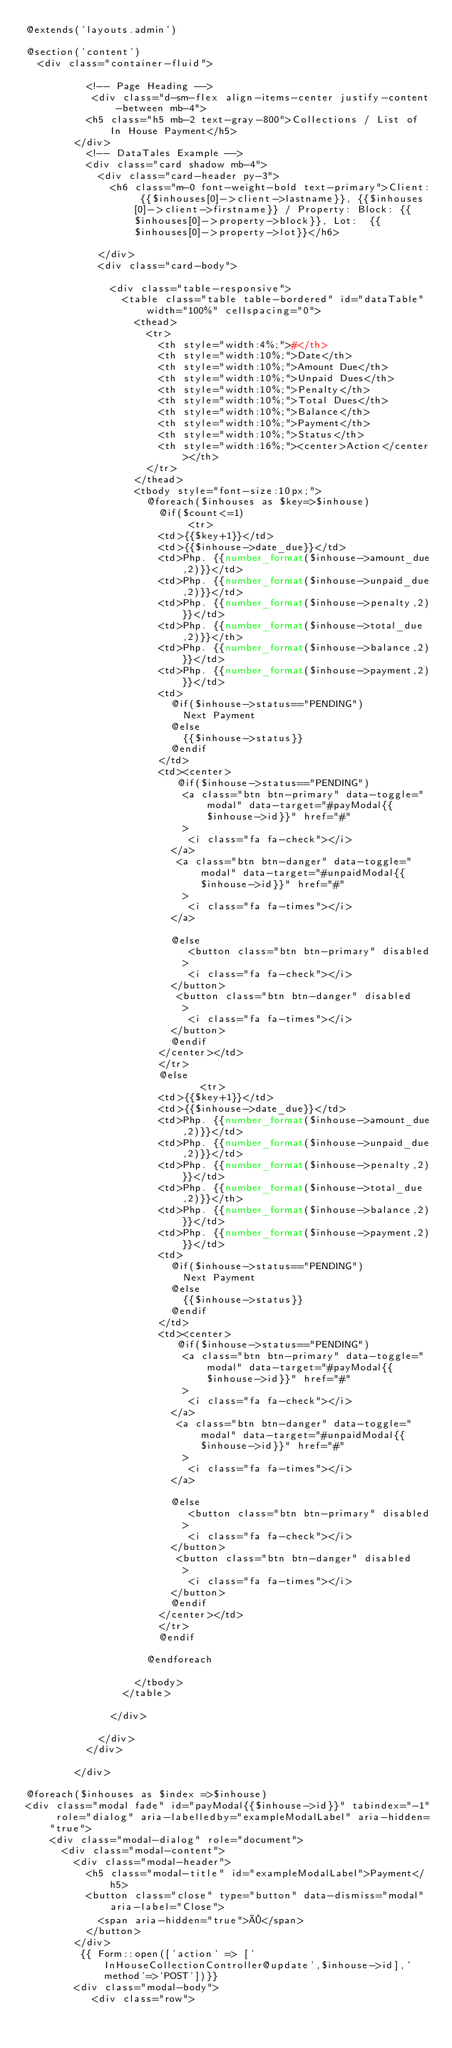<code> <loc_0><loc_0><loc_500><loc_500><_PHP_>@extends('layouts.admin')

@section('content')
  <div class="container-fluid">

          <!-- Page Heading -->
           <div class="d-sm-flex align-items-center justify-content-between mb-4">
          <h5 class="h5 mb-2 text-gray-800">Collections / List of In House Payment</h5>
        </div>
          <!-- DataTales Example -->
          <div class="card shadow mb-4">
            <div class="card-header py-3">
              <h6 class="m-0 font-weight-bold text-primary">Client: {{$inhouses[0]->client->lastname}}, {{$inhouses[0]->client->firstname}} / Property: Block: {{$inhouses[0]->property->block}}, Lot:  {{$inhouses[0]->property->lot}}</h6>

            </div>
            <div class="card-body">
            
              <div class="table-responsive">
                <table class="table table-bordered" id="dataTable" width="100%" cellspacing="0">
                  <thead>
                    <tr>
                      <th style="width:4%;">#</th>
                      <th style="width:10%;">Date</th>
                      <th style="width:10%;">Amount Due</th>
                      <th style="width:10%;">Unpaid Dues</th>
                      <th style="width:10%;">Penalty</th>
                      <th style="width:10%;">Total Dues</th>
                      <th style="width:10%;">Balance</th>
                      <th style="width:10%;">Payment</th>
                      <th style="width:10%;">Status</th>
                      <th style="width:16%;"><center>Action</center></th>
                    </tr>
                  </thead>
                  <tbody style="font-size:10px;">
                    @foreach($inhouses as $key=>$inhouse)
                      @if($count<=1)
                           <tr>
                      <td>{{$key+1}}</td>
                      <td>{{$inhouse->date_due}}</td>
                      <td>Php. {{number_format($inhouse->amount_due,2)}}</td>
                      <td>Php. {{number_format($inhouse->unpaid_due,2)}}</td>
                      <td>Php. {{number_format($inhouse->penalty,2)}}</td>
                      <td>Php. {{number_format($inhouse->total_due,2)}}</th>
                      <td>Php. {{number_format($inhouse->balance,2)}}</td>
                      <td>Php. {{number_format($inhouse->payment,2)}}</td>
                      <td>
                        @if($inhouse->status=="PENDING")
                          Next Payment
                        @else
                          {{$inhouse->status}}
                        @endif
                      </td>
                      <td><center>
                         @if($inhouse->status=="PENDING")
                          <a class="btn btn-primary" data-toggle="modal" data-target="#payModal{{$inhouse->id}}" href="#"
                          >
                           <i class="fa fa-check"></i>
                        </a>
                         <a class="btn btn-danger" data-toggle="modal" data-target="#unpaidModal{{$inhouse->id}}" href="#"
                          >
                           <i class="fa fa-times"></i>
                        </a>
                       
                        @else
                           <button class="btn btn-primary" disabled
                          >
                           <i class="fa fa-check"></i>
                        </button>
                         <button class="btn btn-danger" disabled
                          >
                           <i class="fa fa-times"></i>
                        </button>
                        @endif
                      </center></td>
                      </tr>
                      @else
                             <tr>
                      <td>{{$key+1}}</td>
                      <td>{{$inhouse->date_due}}</td>
                      <td>Php. {{number_format($inhouse->amount_due,2)}}</td>
                      <td>Php. {{number_format($inhouse->unpaid_due,2)}}</td>
                      <td>Php. {{number_format($inhouse->penalty,2)}}</td>
                      <td>Php. {{number_format($inhouse->total_due,2)}}</th>
                      <td>Php. {{number_format($inhouse->balance,2)}}</td>
                      <td>Php. {{number_format($inhouse->payment,2)}}</td>
                      <td>
                        @if($inhouse->status=="PENDING")
                          Next Payment
                        @else
                          {{$inhouse->status}}
                        @endif
                      </td>
                      <td><center>
                         @if($inhouse->status=="PENDING")
                          <a class="btn btn-primary" data-toggle="modal" data-target="#payModal{{$inhouse->id}}" href="#"
                          >
                           <i class="fa fa-check"></i>
                        </a>
                         <a class="btn btn-danger" data-toggle="modal" data-target="#unpaidModal{{$inhouse->id}}" href="#"
                          >
                           <i class="fa fa-times"></i>
                        </a>
                       
                        @else
                           <button class="btn btn-primary" disabled
                          >
                           <i class="fa fa-check"></i>
                        </button>
                         <button class="btn btn-danger" disabled
                          >
                           <i class="fa fa-times"></i>
                        </button>
                        @endif
                      </center></td>
                      </tr>
                      @endif
                   
                    @endforeach
                     
                  </tbody>
                </table>
              
              </div>
            
            </div>
          </div>

        </div>

@foreach($inhouses as $index =>$inhouse)
<div class="modal fade" id="payModal{{$inhouse->id}}" tabindex="-1" role="dialog" aria-labelledby="exampleModalLabel" aria-hidden="true">
    <div class="modal-dialog" role="document">
      <div class="modal-content">
        <div class="modal-header">
          <h5 class="modal-title" id="exampleModalLabel">Payment</h5>
          <button class="close" type="button" data-dismiss="modal" aria-label="Close">
            <span aria-hidden="true">×</span>
          </button>
        </div>
         {{ Form::open(['action' => ['InHouseCollectionController@update',$inhouse->id],'method'=>'POST'])}}
        <div class="modal-body">
           <div class="row">
             </code> 